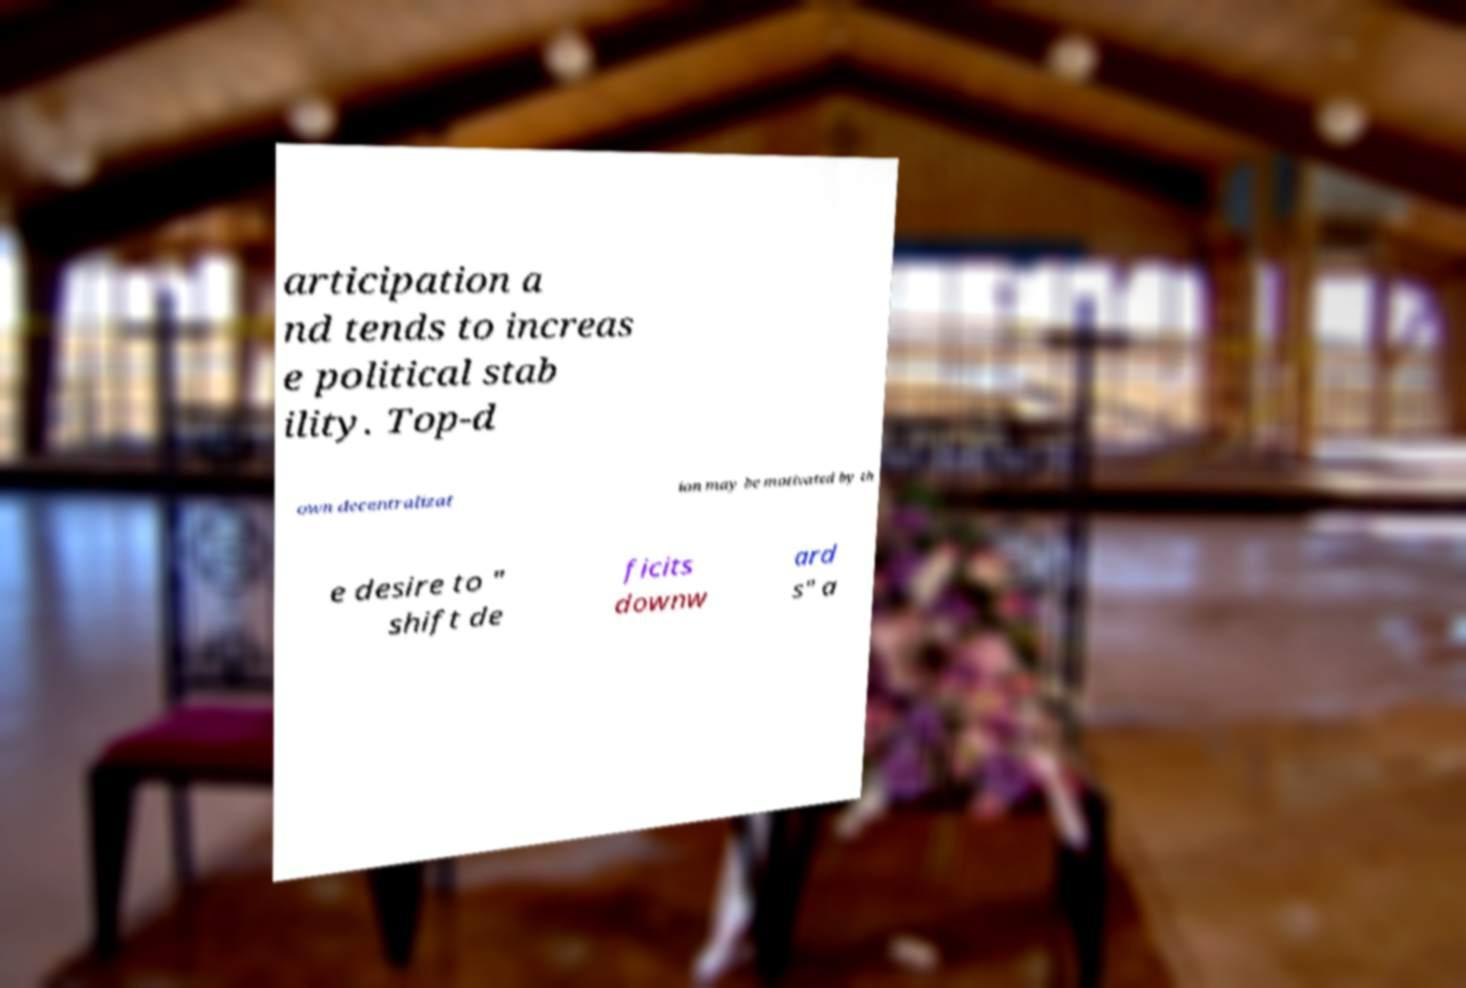Can you accurately transcribe the text from the provided image for me? articipation a nd tends to increas e political stab ility. Top-d own decentralizat ion may be motivated by th e desire to " shift de ficits downw ard s" a 